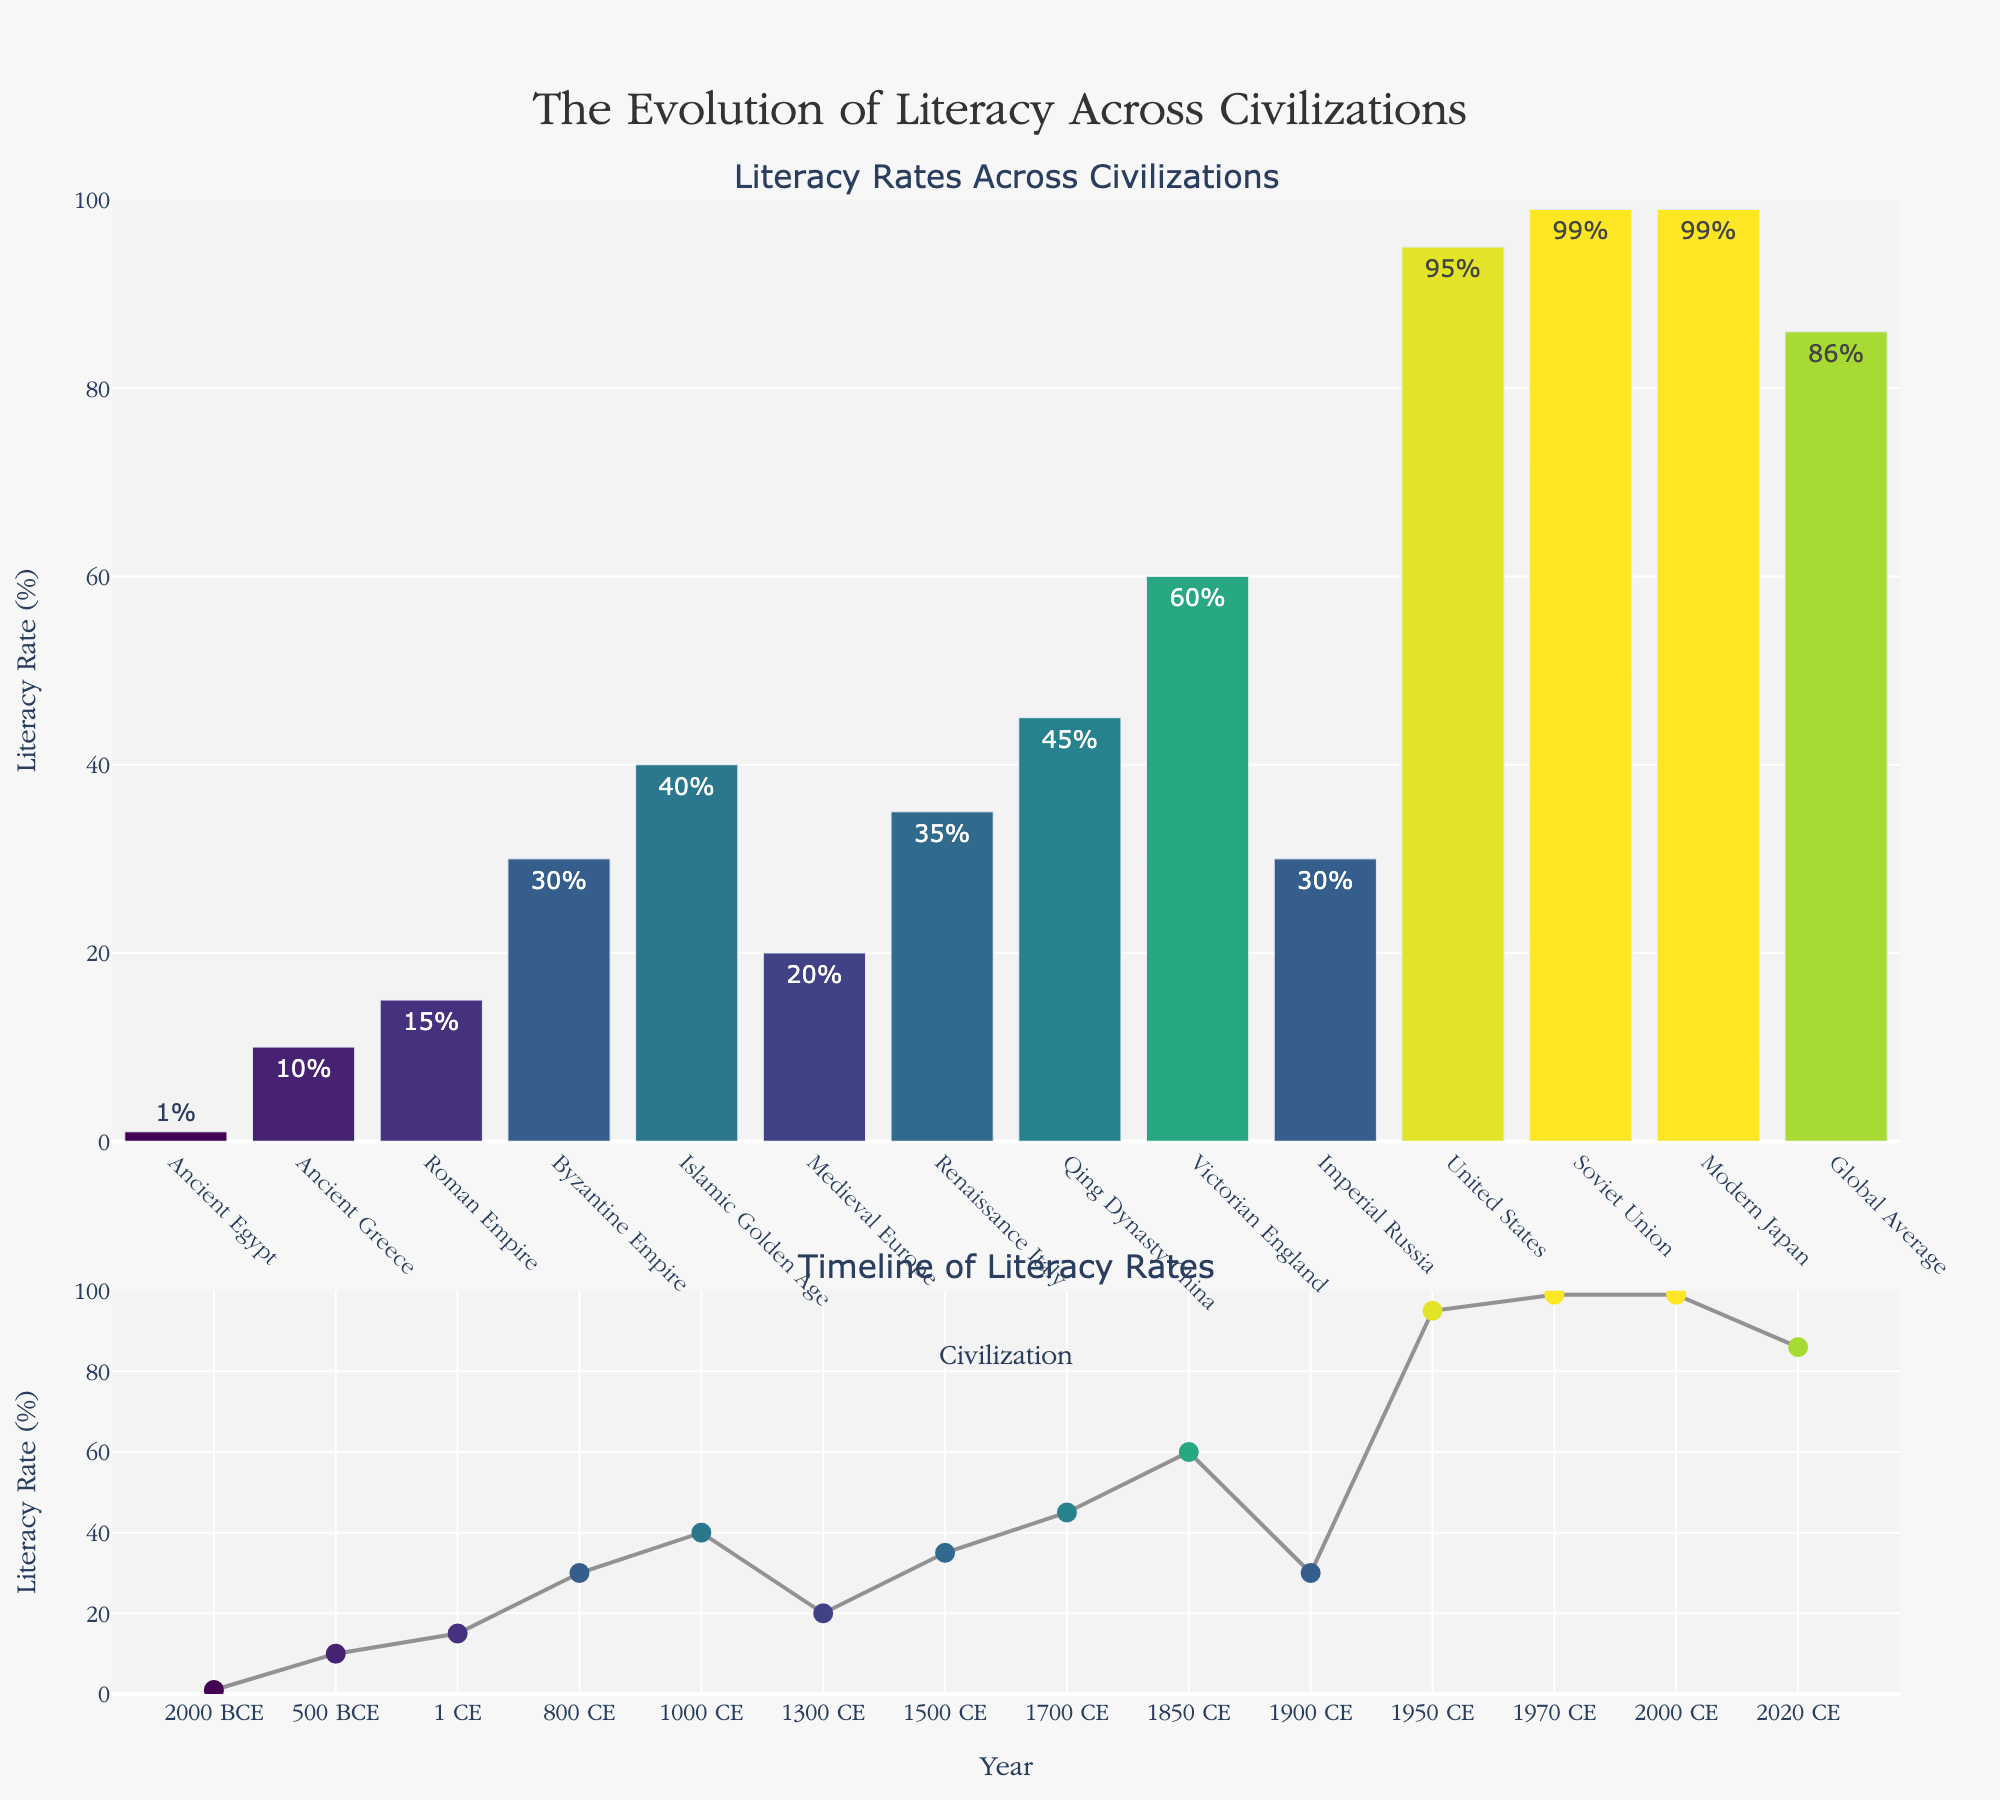How many civilizations are presented in the bar chart? Count the number of bars representing different civilizations in the bar chart part of the subplot.
Answer: 13 What is the literacy rate of the Byzantine Empire? Look for the bar labeled "Byzantine Empire" and read its height or the text on top of it.
Answer: 30% Which civilization has the highest literacy rate? Identify the tallest bar in the bar chart and check its label.
Answer: Soviet Union and Modern Japan (both 99%) What is the title of the entire figure? Read the title displayed at the top of the figure.
Answer: The Evolution of Literacy Across Civilizations Which period in history showed the first significant rise in literacy rates on the timeline? Check the timeline on the second subplot and look for the earliest point where the literacy rate rises noticeably from its predecessors. This happens around the Byzantine Empire.
Answer: Byzantine Empire (approximately 800 CE) How does the literacy rate in Islamic Golden Age compare to that in Medieval Europe? Compare the heights of the bars or the markers on the timeline for "Islamic Golden Age" and "Medieval Europe."
Answer: Islamic Golden Age (40%) is higher than Medieval Europe (20%) What is the average literacy rate of all civilizations combined? Sum all the literacy rates from the dataset, then divide by the number of civilizations. Average = (1+10+15+30+40+20+35+45+60+30+95+99+99+86)/14 = 50.36% (Note: Global Average is part of the data, it should be included)
Answer: 50.36% Between which two periods did the literacy rate increase the most? Look at the timeline and determine where the steepest increase in literacy rate occurs. It would be between the points with the largest vertical gap.
Answer: Between Imperial Russia (30%) and United States (95%) (1950 CE) How does the literacy rate in 2020 CE (Global Average) compare to that of Ancient Greece? Compare the bar heights or timeline markers for "Global Average, 2020 CE" and "Ancient Greece." Global Average (86%) is significantly higher than Ancient Greece (10%).
Answer: Global Average is much higher 